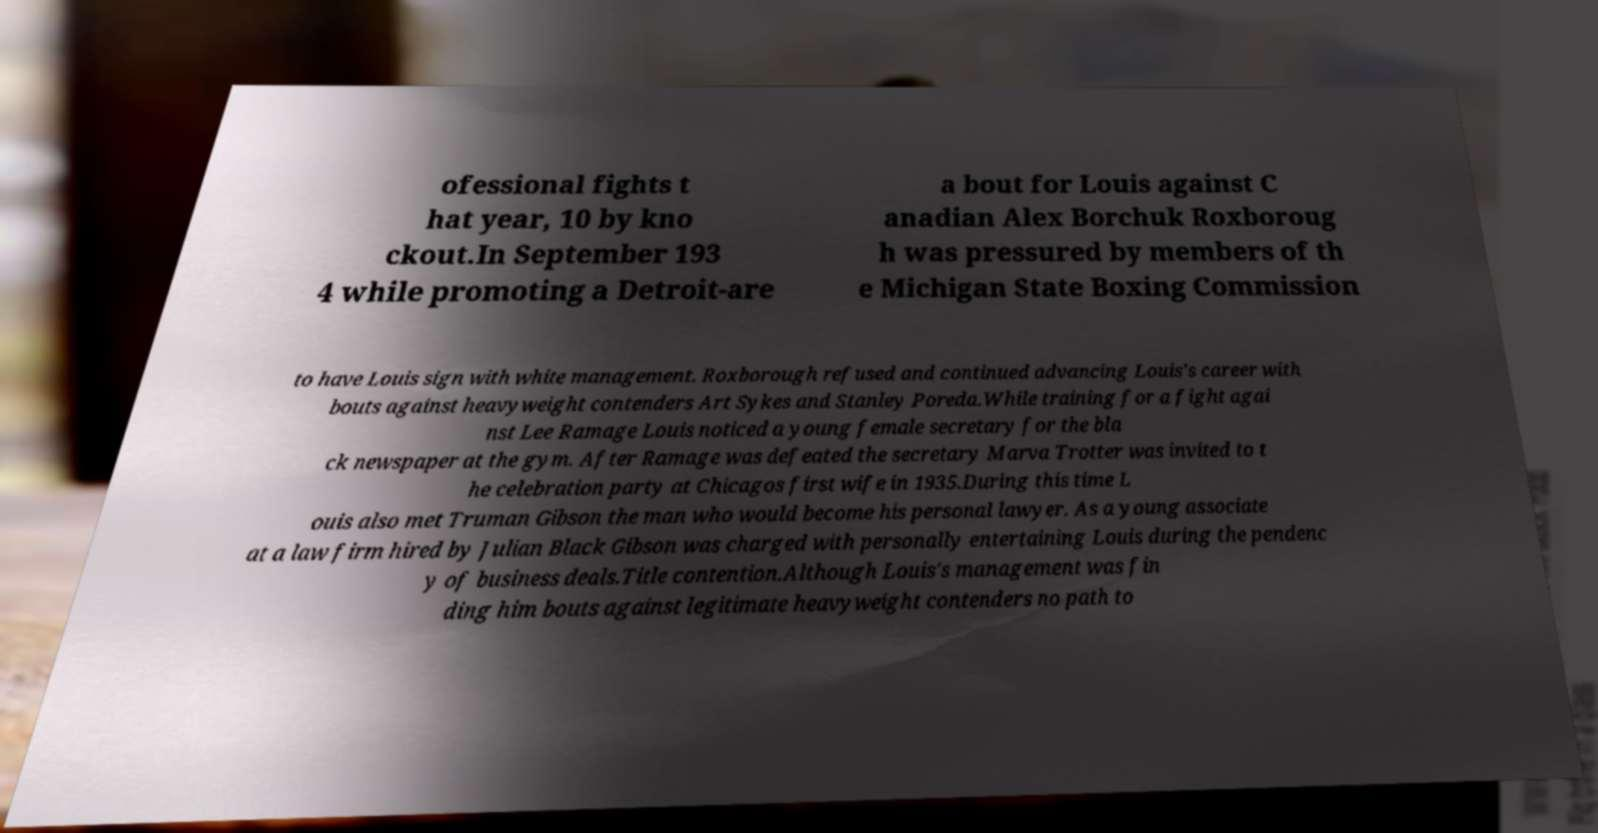Can you read and provide the text displayed in the image?This photo seems to have some interesting text. Can you extract and type it out for me? ofessional fights t hat year, 10 by kno ckout.In September 193 4 while promoting a Detroit-are a bout for Louis against C anadian Alex Borchuk Roxboroug h was pressured by members of th e Michigan State Boxing Commission to have Louis sign with white management. Roxborough refused and continued advancing Louis's career with bouts against heavyweight contenders Art Sykes and Stanley Poreda.While training for a fight agai nst Lee Ramage Louis noticed a young female secretary for the bla ck newspaper at the gym. After Ramage was defeated the secretary Marva Trotter was invited to t he celebration party at Chicagos first wife in 1935.During this time L ouis also met Truman Gibson the man who would become his personal lawyer. As a young associate at a law firm hired by Julian Black Gibson was charged with personally entertaining Louis during the pendenc y of business deals.Title contention.Although Louis's management was fin ding him bouts against legitimate heavyweight contenders no path to 